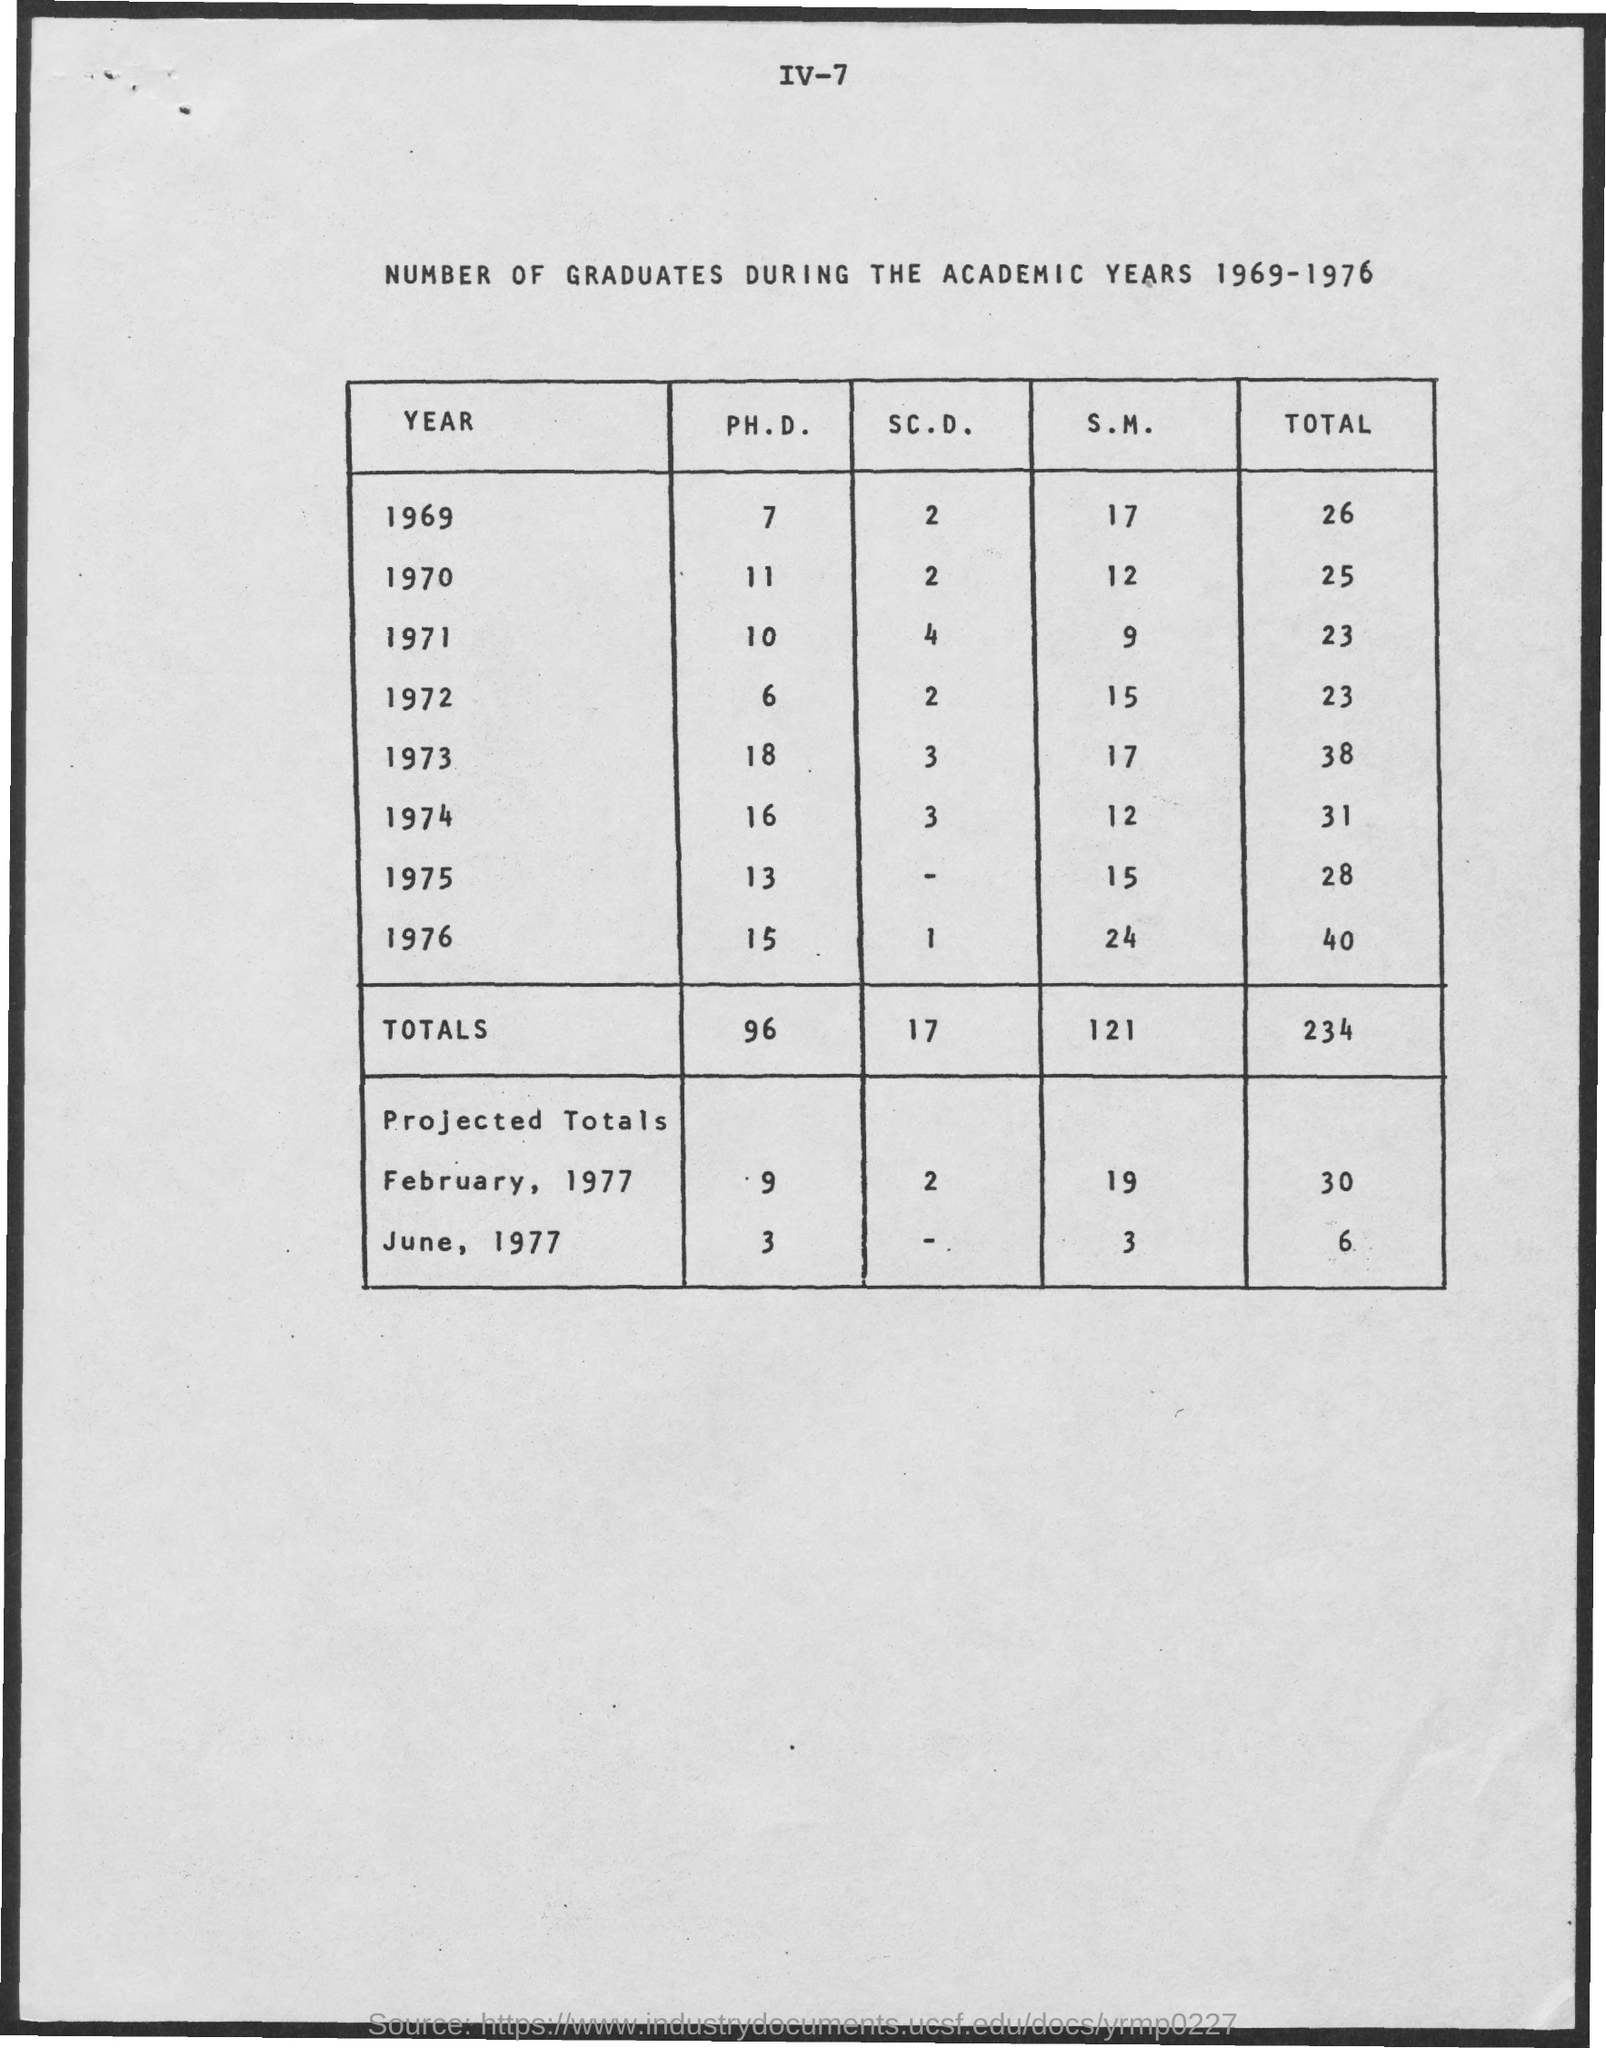Indicate a few pertinent items in this graphic. In 1976, the total of 40 is... 